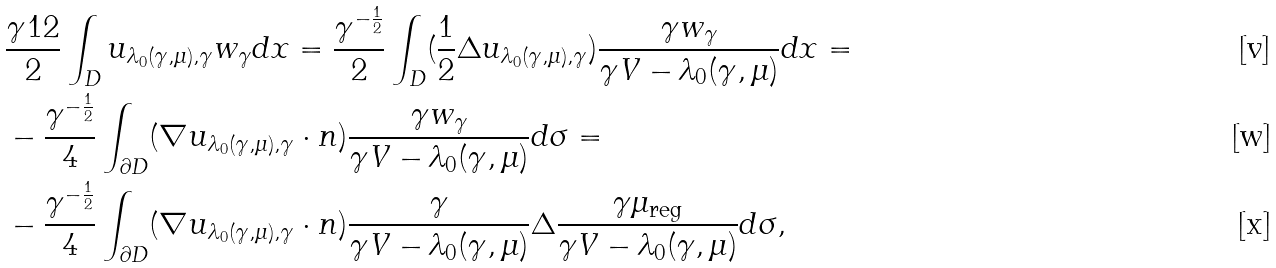Convert formula to latex. <formula><loc_0><loc_0><loc_500><loc_500>& \frac { \gamma ^ { } { 1 } 2 } 2 \int _ { D } u _ { \lambda _ { 0 } ( \gamma , \mu ) , \gamma } w _ { \gamma } d x = \frac { \gamma ^ { - \frac { 1 } { 2 } } } 2 \int _ { D } ( \frac { 1 } { 2 } \Delta u _ { \lambda _ { 0 } ( \gamma , \mu ) , \gamma } ) \frac { \gamma w _ { \gamma } } { \gamma V - \lambda _ { 0 } ( \gamma , \mu ) } d x = \\ & - \frac { \gamma ^ { - \frac { 1 } { 2 } } } 4 \int _ { \partial D } ( \nabla u _ { \lambda _ { 0 } ( \gamma , \mu ) , \gamma } \cdot n ) \frac { \gamma w _ { \gamma } } { \gamma V - \lambda _ { 0 } ( \gamma , \mu ) } d \sigma = \\ & - \frac { \gamma ^ { - \frac { 1 } { 2 } } } 4 \int _ { \partial D } ( \nabla u _ { \lambda _ { 0 } ( \gamma , \mu ) , \gamma } \cdot n ) \frac { \gamma } { \gamma V - \lambda _ { 0 } ( \gamma , \mu ) } \Delta \frac { \gamma \mu _ { \text {reg} } } { \gamma V - \lambda _ { 0 } ( \gamma , \mu ) } d \sigma ,</formula> 